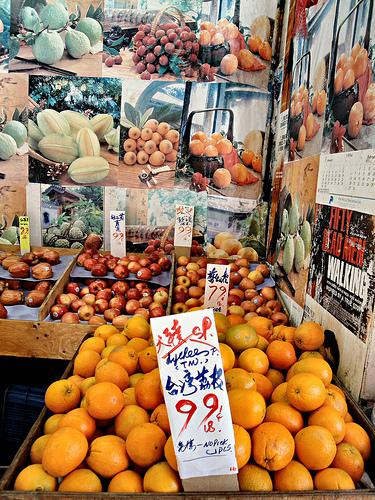Question: what item is being sold in the foreground for .99 cents a pound?
Choices:
A. Grapes.
B. Corn.
C. Nuts.
D. Oranges.
Answer with the letter. Answer: D Question: what color are the oranges?
Choices:
A. Orange.
B. Teal.
C. Purple.
D. Neon.
Answer with the letter. Answer: A Question: where was this photo taken?
Choices:
A. Fair.
B. Circus.
C. Under water.
D. Fruit shop.
Answer with the letter. Answer: D Question: what does the sign under the calendar on the far right say?
Choices:
A. Private.
B. FIFTY DEAD MEN WALKING.
C. One way to home.
D. Follow the yellow brick road.
Answer with the letter. Answer: B Question: what is directly above the FIFTY DEAD MEN WALKING sign?
Choices:
A. A light.
B. A smoke alarm.
C. A sprinkler.
D. Calendar.
Answer with the letter. Answer: D Question: what color is the .99 on the sign?
Choices:
A. Purple.
B. Teal.
C. Red.
D. Neon.
Answer with the letter. Answer: C Question: who is standing next to the oranges?
Choices:
A. A man.
B. No one.
C. An old woman.
D. A child.
Answer with the letter. Answer: B 